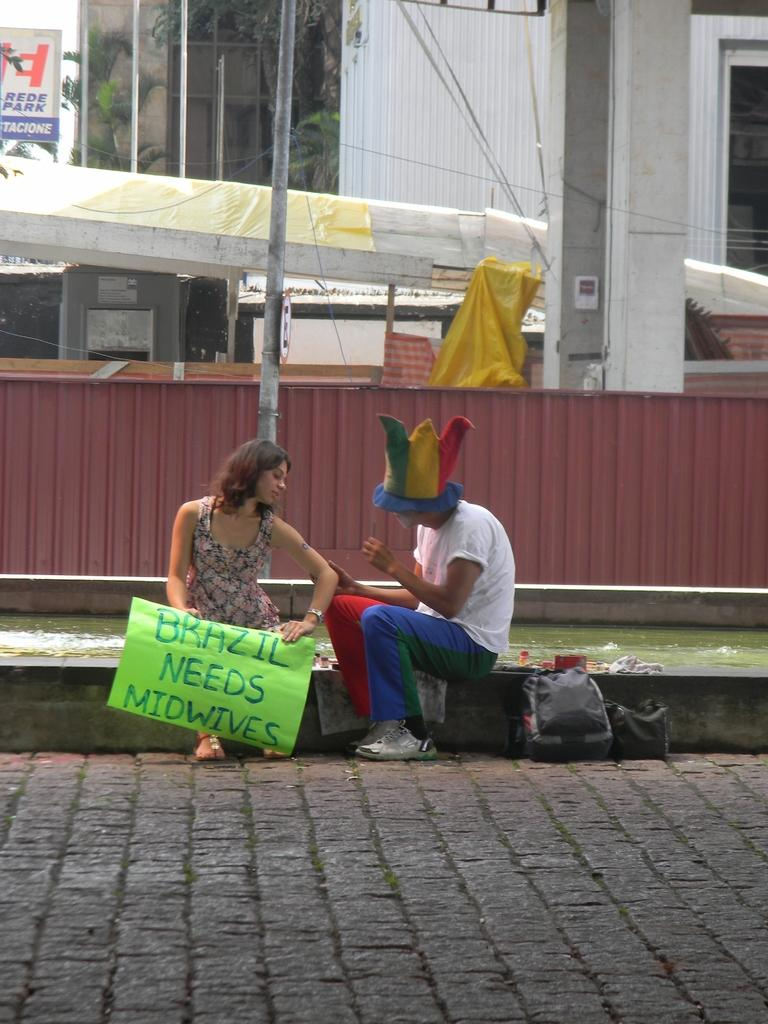How many people are present in the image? There are two people, a man and a woman, present in the image. What is the woman holding in the image? The woman is holding a placard. What can be seen in the background of the image? There are boards, a building, and trees in the background of the image. What type of mine can be seen in the background of the image? There is no mine present in the image; it features a woman holding a placard and a background with boards, a building, and trees. 